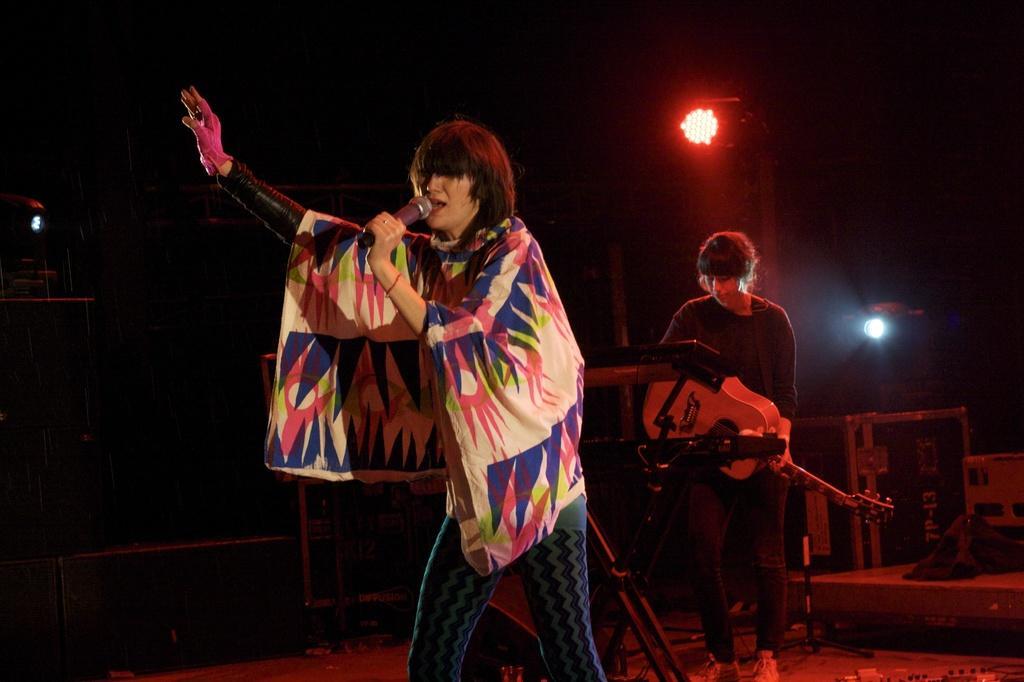Can you describe this image briefly? In this picture there is a person holding a microphone and singing, behind this person we can a person playing a guitar and we can see devices. In the background of the image it is dark and we can see the lights. 